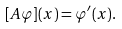<formula> <loc_0><loc_0><loc_500><loc_500>[ A \varphi ] ( x ) = { \varphi } ^ { \prime } ( x ) .</formula> 